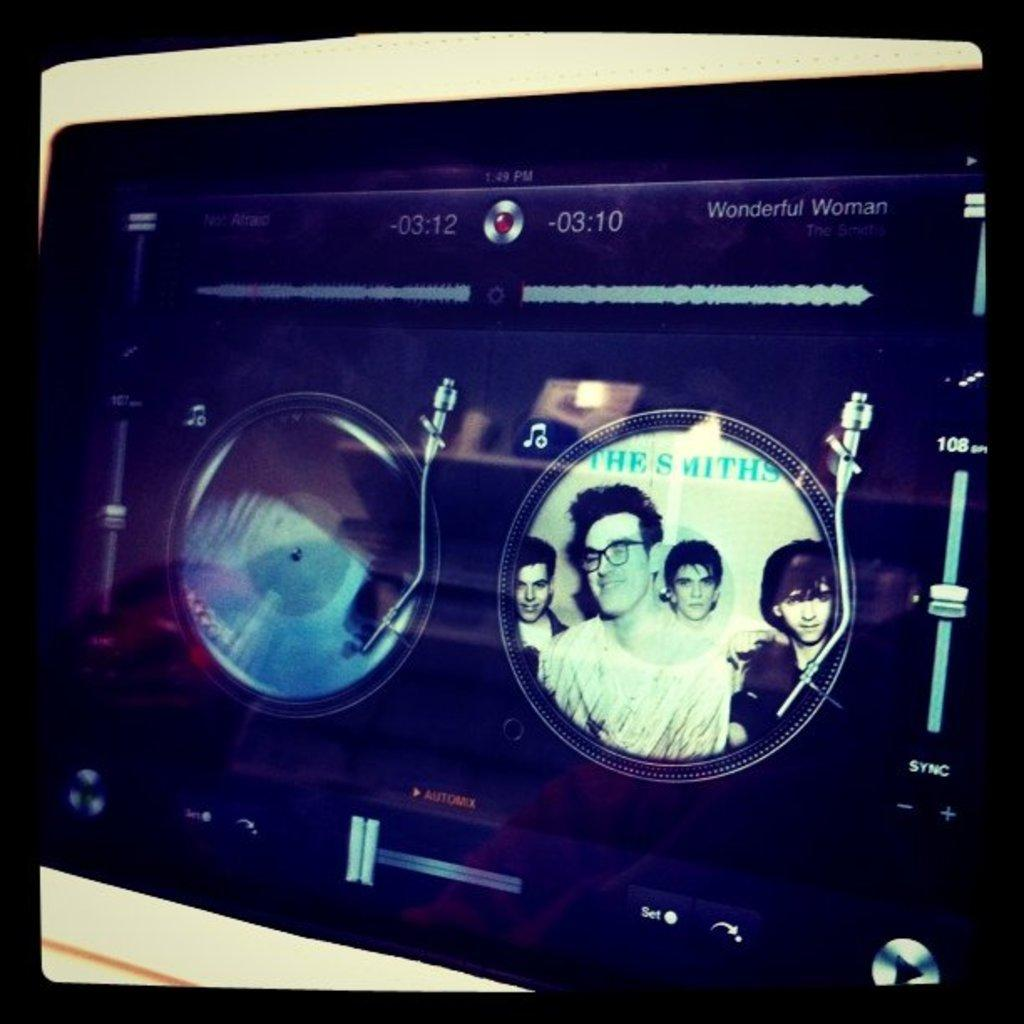What is displayed on the screen in the image? There is an image of people on the screen in the image. What other elements can be seen on the screen besides the image of people? There are buttons, text, and numbers visible on the screen. Can you describe the text present on the screen? Unfortunately, the specific text cannot be described without more information. What type of numbers are visible on the screen? The numbers visible on the screen are unspecified, so their type cannot be determined. How many women are present in the image, and where is the camp located? The provided facts do not mention any women or a camp in the image, so we cannot answer these questions based on the information given. 